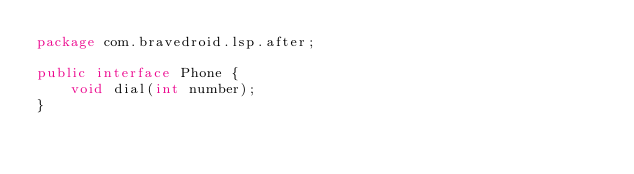Convert code to text. <code><loc_0><loc_0><loc_500><loc_500><_Java_>package com.bravedroid.lsp.after;

public interface Phone {
    void dial(int number);
}
</code> 